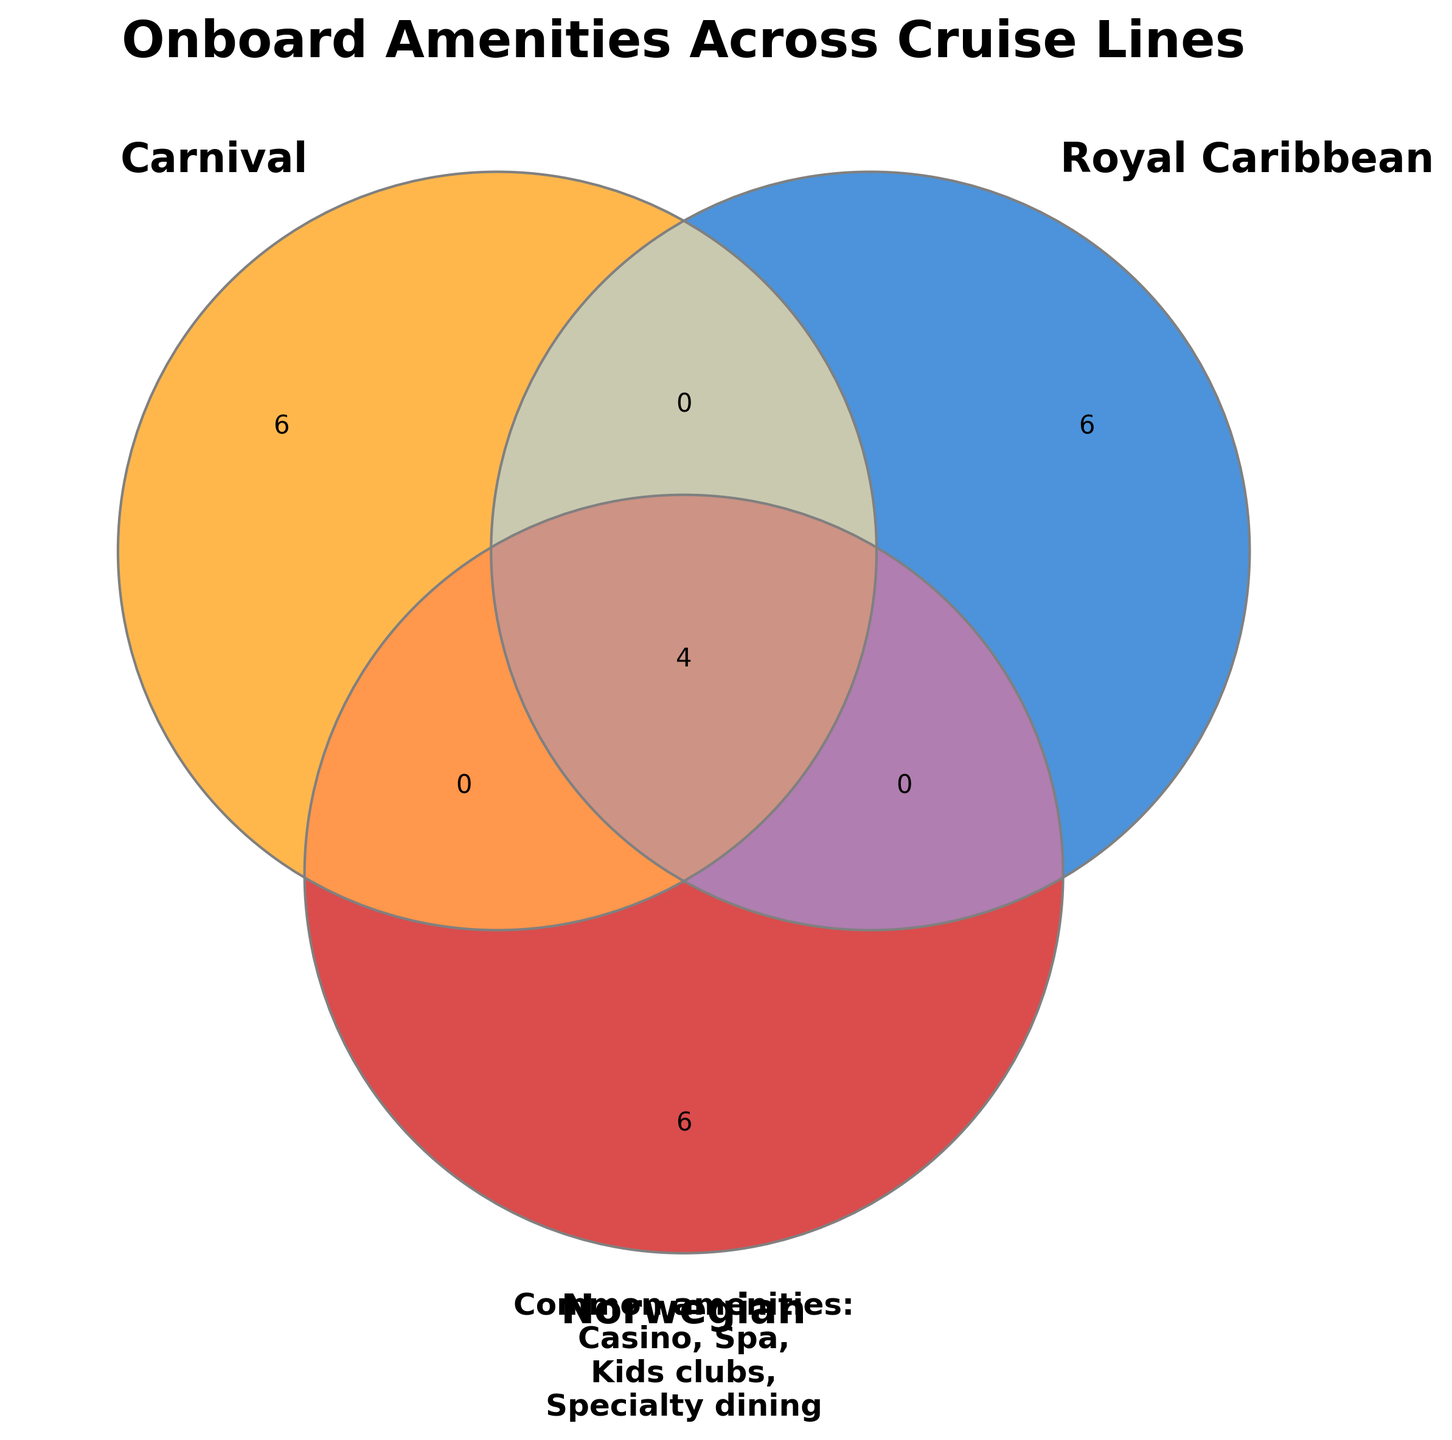What is the title of the Venn diagram? The title is usually located at the top of the figure. The title in this Venn diagram is "Onboard Amenities Across Cruise Lines".
Answer: Onboard Amenities Across Cruise Lines What unique amenities does Carnival offer that are not shared with Royal Caribbean or Norwegian? Look at the circle labeled "Carnival" and check the section that does not overlap with any other circles. The unique amenities of Carnival are Waterslides, Broadway shows, Mini-golf, Sports bar, Comedy club, and Piano bar.
Answer: Waterslides, Broadway shows, Mini-golf, Sports bar, Comedy club, Piano bar Which amenities are common to all three cruise lines? Identify the overlapping area of all three circles (Carnival, Royal Caribbean, Norwegian). The common amenities are Casino, Spa, Kids clubs, and Specialty dining.
Answer: Casino, Spa, Kids clubs, Specialty dining How many amenities does Norwegian have in common with Royal Caribbean but not with Carnival? Check the overlapping area between Norwegian and Royal Caribbean circles, but outside the Carnival circle. The amenities are Zipline, FlowRider, and Laser tag.
Answer: 3 Which amenities are only offered by Royal Caribbean? Look at the sections of the Royal Caribbean circle that do not overlap with any other circles. The unique amenities of Royal Caribbean are Rock climbing, Ice skating, and Central Park.
Answer: Rock climbing, Ice skating, Central Park Which cruise line offers the most unique amenities not shared with the others? Compare the non-overlapping sections of each circle. Carnival's unique amenities are six, Royal Caribbean's unique amenities are three, and Norwegian's unique amenities are three. Therefore, Carnival offers the most unique amenities.
Answer: Carnival Are there any amenities that are only shared between Carnival and Norwegian? Look at the overlapping section between the Carnival and Norwegian circles that does not overlap with the Royal Caribbean circle. There are no such amenities.
Answer: No Among the shared amenities, which ones do not include Royal Caribbean? Look at the sections that include overlapping between Carnival and Norwegian without Royal Caribbean. There are no amenities shared only by Carnival and Norwegian.
Answer: None Which amenities are shared between Royal Caribbean and Norwegian, but not with Carnival? Identify the area of overlap between Royal Caribbean and Norwegian without including Carnival. The amenities are Laser tag, Race track, and Zipline.
Answer: Laser tag, Race track, Zipline 